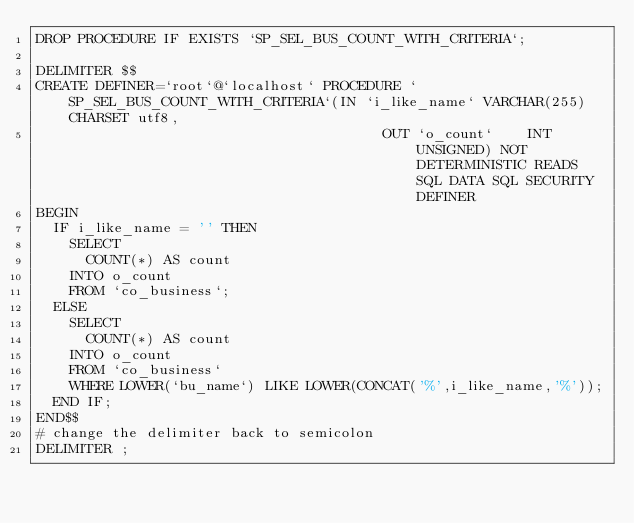Convert code to text. <code><loc_0><loc_0><loc_500><loc_500><_SQL_>DROP PROCEDURE IF EXISTS `SP_SEL_BUS_COUNT_WITH_CRITERIA`;

DELIMITER $$
CREATE DEFINER=`root`@`localhost` PROCEDURE `SP_SEL_BUS_COUNT_WITH_CRITERIA`(IN `i_like_name` VARCHAR(255) CHARSET utf8,
																		     OUT `o_count`    INT UNSIGNED) NOT DETERMINISTIC READS SQL DATA SQL SECURITY DEFINER
BEGIN
	IF i_like_name = '' THEN
		SELECT
			COUNT(*) AS count
		INTO o_count
		FROM `co_business`;
	ELSE
		SELECT
			COUNT(*) AS count
		INTO o_count
		FROM `co_business`
		WHERE LOWER(`bu_name`) LIKE LOWER(CONCAT('%',i_like_name,'%'));
	END IF;
END$$
# change the delimiter back to semicolon
DELIMITER ;</code> 